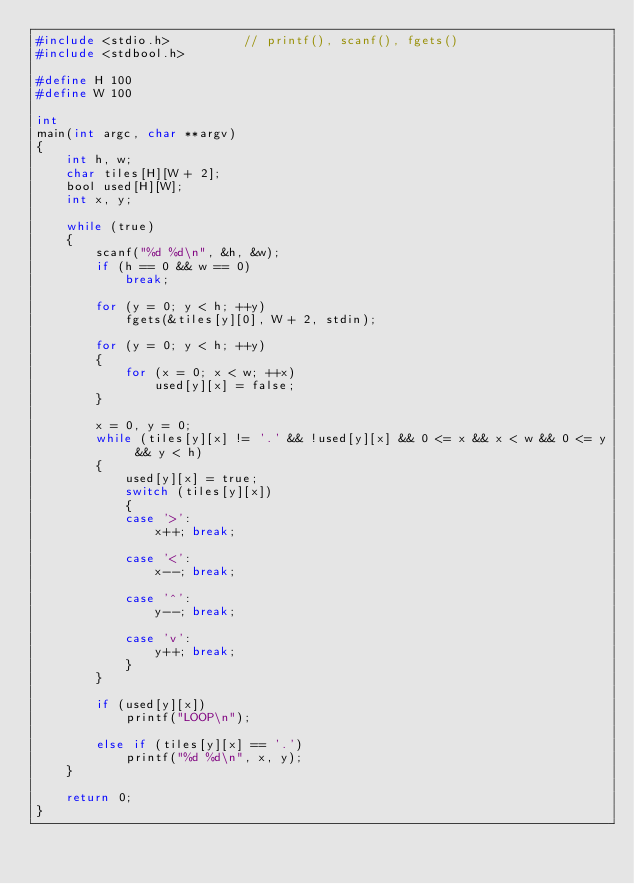<code> <loc_0><loc_0><loc_500><loc_500><_C_>#include <stdio.h>          // printf(), scanf(), fgets()
#include <stdbool.h>

#define H 100
#define W 100

int
main(int argc, char **argv)
{
	int h, w;
	char tiles[H][W + 2];
	bool used[H][W];
	int x, y;

	while (true)
	{
		scanf("%d %d\n", &h, &w);
		if (h == 0 && w == 0)
			break;

		for (y = 0; y < h; ++y)
			fgets(&tiles[y][0], W + 2, stdin);

		for (y = 0; y < h; ++y)
		{
			for (x = 0; x < w; ++x)
				used[y][x] = false;
		}

		x = 0, y = 0;
		while (tiles[y][x] != '.' && !used[y][x] && 0 <= x && x < w && 0 <= y && y < h)
		{
			used[y][x] = true;
			switch (tiles[y][x])
			{
			case '>':
				x++; break;

			case '<':
				x--; break;

			case '^':
				y--; break;

			case 'v':
				y++; break;
			}
		}

		if (used[y][x])
			printf("LOOP\n");

		else if (tiles[y][x] == '.')
			printf("%d %d\n", x, y);
	}

	return 0;
}</code> 